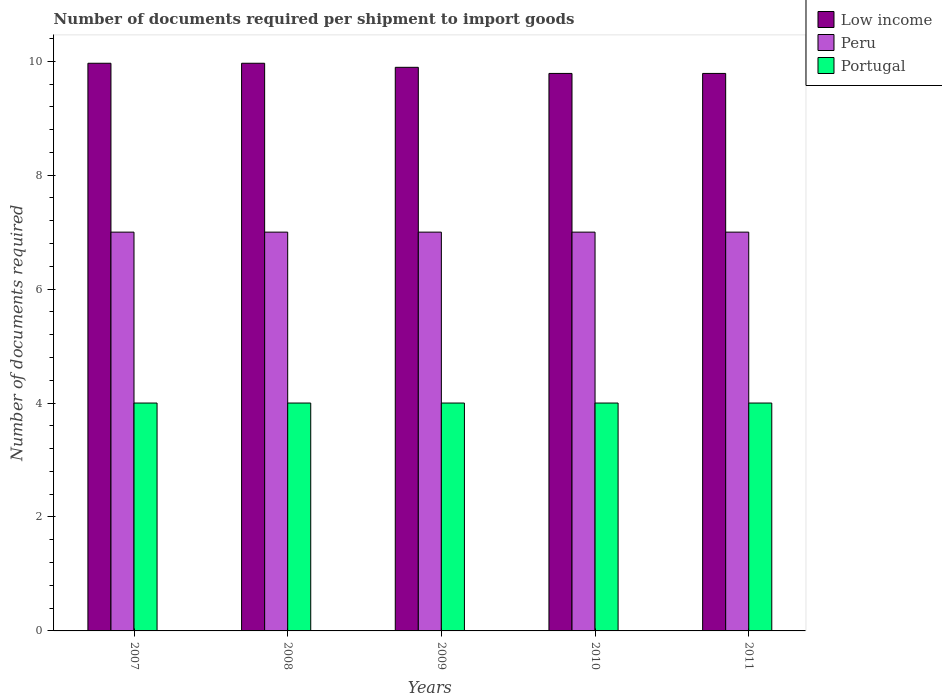Are the number of bars on each tick of the X-axis equal?
Your response must be concise. Yes. How many bars are there on the 5th tick from the left?
Keep it short and to the point. 3. How many bars are there on the 5th tick from the right?
Provide a succinct answer. 3. What is the label of the 1st group of bars from the left?
Provide a succinct answer. 2007. In how many cases, is the number of bars for a given year not equal to the number of legend labels?
Provide a succinct answer. 0. What is the number of documents required per shipment to import goods in Low income in 2007?
Keep it short and to the point. 9.96. Across all years, what is the maximum number of documents required per shipment to import goods in Peru?
Ensure brevity in your answer.  7. Across all years, what is the minimum number of documents required per shipment to import goods in Peru?
Provide a succinct answer. 7. In which year was the number of documents required per shipment to import goods in Peru minimum?
Your answer should be very brief. 2007. What is the total number of documents required per shipment to import goods in Portugal in the graph?
Ensure brevity in your answer.  20. What is the difference between the number of documents required per shipment to import goods in Peru in 2007 and that in 2010?
Give a very brief answer. 0. What is the difference between the number of documents required per shipment to import goods in Portugal in 2011 and the number of documents required per shipment to import goods in Low income in 2009?
Provide a succinct answer. -5.89. What is the average number of documents required per shipment to import goods in Low income per year?
Ensure brevity in your answer.  9.88. In the year 2009, what is the difference between the number of documents required per shipment to import goods in Portugal and number of documents required per shipment to import goods in Peru?
Give a very brief answer. -3. In how many years, is the number of documents required per shipment to import goods in Low income greater than 4?
Your response must be concise. 5. What is the ratio of the number of documents required per shipment to import goods in Portugal in 2007 to that in 2010?
Give a very brief answer. 1. Is the number of documents required per shipment to import goods in Low income in 2010 less than that in 2011?
Your response must be concise. No. What is the difference between the highest and the second highest number of documents required per shipment to import goods in Low income?
Keep it short and to the point. 0. Is the sum of the number of documents required per shipment to import goods in Portugal in 2009 and 2010 greater than the maximum number of documents required per shipment to import goods in Peru across all years?
Your response must be concise. Yes. How many years are there in the graph?
Your answer should be compact. 5. What is the difference between two consecutive major ticks on the Y-axis?
Your response must be concise. 2. Are the values on the major ticks of Y-axis written in scientific E-notation?
Provide a short and direct response. No. How many legend labels are there?
Make the answer very short. 3. How are the legend labels stacked?
Your answer should be very brief. Vertical. What is the title of the graph?
Offer a very short reply. Number of documents required per shipment to import goods. What is the label or title of the X-axis?
Offer a terse response. Years. What is the label or title of the Y-axis?
Keep it short and to the point. Number of documents required. What is the Number of documents required of Low income in 2007?
Give a very brief answer. 9.96. What is the Number of documents required of Portugal in 2007?
Give a very brief answer. 4. What is the Number of documents required of Low income in 2008?
Provide a succinct answer. 9.96. What is the Number of documents required of Low income in 2009?
Offer a terse response. 9.89. What is the Number of documents required of Peru in 2009?
Keep it short and to the point. 7. What is the Number of documents required of Low income in 2010?
Ensure brevity in your answer.  9.79. What is the Number of documents required in Portugal in 2010?
Offer a very short reply. 4. What is the Number of documents required of Low income in 2011?
Offer a very short reply. 9.79. What is the Number of documents required of Peru in 2011?
Provide a succinct answer. 7. Across all years, what is the maximum Number of documents required in Low income?
Offer a terse response. 9.96. Across all years, what is the maximum Number of documents required of Peru?
Give a very brief answer. 7. Across all years, what is the minimum Number of documents required in Low income?
Your answer should be very brief. 9.79. Across all years, what is the minimum Number of documents required of Peru?
Provide a short and direct response. 7. What is the total Number of documents required in Low income in the graph?
Give a very brief answer. 49.39. What is the total Number of documents required of Portugal in the graph?
Ensure brevity in your answer.  20. What is the difference between the Number of documents required in Low income in 2007 and that in 2008?
Make the answer very short. 0. What is the difference between the Number of documents required of Peru in 2007 and that in 2008?
Provide a succinct answer. 0. What is the difference between the Number of documents required of Portugal in 2007 and that in 2008?
Ensure brevity in your answer.  0. What is the difference between the Number of documents required of Low income in 2007 and that in 2009?
Make the answer very short. 0.07. What is the difference between the Number of documents required in Peru in 2007 and that in 2009?
Provide a short and direct response. 0. What is the difference between the Number of documents required of Low income in 2007 and that in 2010?
Offer a terse response. 0.18. What is the difference between the Number of documents required of Low income in 2007 and that in 2011?
Provide a short and direct response. 0.18. What is the difference between the Number of documents required of Peru in 2007 and that in 2011?
Offer a terse response. 0. What is the difference between the Number of documents required of Portugal in 2007 and that in 2011?
Your response must be concise. 0. What is the difference between the Number of documents required of Low income in 2008 and that in 2009?
Provide a short and direct response. 0.07. What is the difference between the Number of documents required in Peru in 2008 and that in 2009?
Ensure brevity in your answer.  0. What is the difference between the Number of documents required in Portugal in 2008 and that in 2009?
Give a very brief answer. 0. What is the difference between the Number of documents required of Low income in 2008 and that in 2010?
Give a very brief answer. 0.18. What is the difference between the Number of documents required of Peru in 2008 and that in 2010?
Your answer should be compact. 0. What is the difference between the Number of documents required of Low income in 2008 and that in 2011?
Provide a succinct answer. 0.18. What is the difference between the Number of documents required of Peru in 2008 and that in 2011?
Give a very brief answer. 0. What is the difference between the Number of documents required of Portugal in 2008 and that in 2011?
Give a very brief answer. 0. What is the difference between the Number of documents required in Low income in 2009 and that in 2010?
Keep it short and to the point. 0.11. What is the difference between the Number of documents required of Peru in 2009 and that in 2010?
Your answer should be very brief. 0. What is the difference between the Number of documents required in Low income in 2009 and that in 2011?
Give a very brief answer. 0.11. What is the difference between the Number of documents required of Low income in 2010 and that in 2011?
Provide a succinct answer. 0. What is the difference between the Number of documents required in Peru in 2010 and that in 2011?
Make the answer very short. 0. What is the difference between the Number of documents required of Portugal in 2010 and that in 2011?
Keep it short and to the point. 0. What is the difference between the Number of documents required in Low income in 2007 and the Number of documents required in Peru in 2008?
Your answer should be very brief. 2.96. What is the difference between the Number of documents required in Low income in 2007 and the Number of documents required in Portugal in 2008?
Keep it short and to the point. 5.96. What is the difference between the Number of documents required in Peru in 2007 and the Number of documents required in Portugal in 2008?
Ensure brevity in your answer.  3. What is the difference between the Number of documents required in Low income in 2007 and the Number of documents required in Peru in 2009?
Keep it short and to the point. 2.96. What is the difference between the Number of documents required in Low income in 2007 and the Number of documents required in Portugal in 2009?
Give a very brief answer. 5.96. What is the difference between the Number of documents required of Low income in 2007 and the Number of documents required of Peru in 2010?
Ensure brevity in your answer.  2.96. What is the difference between the Number of documents required of Low income in 2007 and the Number of documents required of Portugal in 2010?
Give a very brief answer. 5.96. What is the difference between the Number of documents required of Peru in 2007 and the Number of documents required of Portugal in 2010?
Your answer should be very brief. 3. What is the difference between the Number of documents required in Low income in 2007 and the Number of documents required in Peru in 2011?
Keep it short and to the point. 2.96. What is the difference between the Number of documents required in Low income in 2007 and the Number of documents required in Portugal in 2011?
Ensure brevity in your answer.  5.96. What is the difference between the Number of documents required of Peru in 2007 and the Number of documents required of Portugal in 2011?
Provide a succinct answer. 3. What is the difference between the Number of documents required of Low income in 2008 and the Number of documents required of Peru in 2009?
Provide a succinct answer. 2.96. What is the difference between the Number of documents required in Low income in 2008 and the Number of documents required in Portugal in 2009?
Offer a terse response. 5.96. What is the difference between the Number of documents required in Low income in 2008 and the Number of documents required in Peru in 2010?
Offer a very short reply. 2.96. What is the difference between the Number of documents required of Low income in 2008 and the Number of documents required of Portugal in 2010?
Keep it short and to the point. 5.96. What is the difference between the Number of documents required of Peru in 2008 and the Number of documents required of Portugal in 2010?
Your response must be concise. 3. What is the difference between the Number of documents required of Low income in 2008 and the Number of documents required of Peru in 2011?
Offer a terse response. 2.96. What is the difference between the Number of documents required in Low income in 2008 and the Number of documents required in Portugal in 2011?
Provide a succinct answer. 5.96. What is the difference between the Number of documents required of Peru in 2008 and the Number of documents required of Portugal in 2011?
Keep it short and to the point. 3. What is the difference between the Number of documents required in Low income in 2009 and the Number of documents required in Peru in 2010?
Your response must be concise. 2.89. What is the difference between the Number of documents required of Low income in 2009 and the Number of documents required of Portugal in 2010?
Keep it short and to the point. 5.89. What is the difference between the Number of documents required in Peru in 2009 and the Number of documents required in Portugal in 2010?
Provide a succinct answer. 3. What is the difference between the Number of documents required of Low income in 2009 and the Number of documents required of Peru in 2011?
Make the answer very short. 2.89. What is the difference between the Number of documents required of Low income in 2009 and the Number of documents required of Portugal in 2011?
Your answer should be compact. 5.89. What is the difference between the Number of documents required in Peru in 2009 and the Number of documents required in Portugal in 2011?
Ensure brevity in your answer.  3. What is the difference between the Number of documents required of Low income in 2010 and the Number of documents required of Peru in 2011?
Offer a terse response. 2.79. What is the difference between the Number of documents required in Low income in 2010 and the Number of documents required in Portugal in 2011?
Make the answer very short. 5.79. What is the average Number of documents required in Low income per year?
Ensure brevity in your answer.  9.88. What is the average Number of documents required in Portugal per year?
Your answer should be very brief. 4. In the year 2007, what is the difference between the Number of documents required in Low income and Number of documents required in Peru?
Provide a short and direct response. 2.96. In the year 2007, what is the difference between the Number of documents required of Low income and Number of documents required of Portugal?
Provide a succinct answer. 5.96. In the year 2007, what is the difference between the Number of documents required of Peru and Number of documents required of Portugal?
Keep it short and to the point. 3. In the year 2008, what is the difference between the Number of documents required in Low income and Number of documents required in Peru?
Keep it short and to the point. 2.96. In the year 2008, what is the difference between the Number of documents required of Low income and Number of documents required of Portugal?
Keep it short and to the point. 5.96. In the year 2008, what is the difference between the Number of documents required in Peru and Number of documents required in Portugal?
Your answer should be very brief. 3. In the year 2009, what is the difference between the Number of documents required in Low income and Number of documents required in Peru?
Your response must be concise. 2.89. In the year 2009, what is the difference between the Number of documents required of Low income and Number of documents required of Portugal?
Your answer should be compact. 5.89. In the year 2009, what is the difference between the Number of documents required in Peru and Number of documents required in Portugal?
Make the answer very short. 3. In the year 2010, what is the difference between the Number of documents required of Low income and Number of documents required of Peru?
Make the answer very short. 2.79. In the year 2010, what is the difference between the Number of documents required of Low income and Number of documents required of Portugal?
Your answer should be compact. 5.79. In the year 2011, what is the difference between the Number of documents required of Low income and Number of documents required of Peru?
Provide a succinct answer. 2.79. In the year 2011, what is the difference between the Number of documents required of Low income and Number of documents required of Portugal?
Offer a terse response. 5.79. What is the ratio of the Number of documents required in Low income in 2007 to that in 2008?
Your answer should be very brief. 1. What is the ratio of the Number of documents required of Portugal in 2007 to that in 2008?
Offer a very short reply. 1. What is the ratio of the Number of documents required of Low income in 2007 to that in 2009?
Offer a terse response. 1.01. What is the ratio of the Number of documents required of Peru in 2007 to that in 2009?
Make the answer very short. 1. What is the ratio of the Number of documents required of Portugal in 2007 to that in 2009?
Your answer should be compact. 1. What is the ratio of the Number of documents required in Low income in 2007 to that in 2010?
Your answer should be very brief. 1.02. What is the ratio of the Number of documents required in Peru in 2007 to that in 2010?
Your answer should be compact. 1. What is the ratio of the Number of documents required in Portugal in 2007 to that in 2010?
Provide a succinct answer. 1. What is the ratio of the Number of documents required of Low income in 2007 to that in 2011?
Offer a terse response. 1.02. What is the ratio of the Number of documents required of Peru in 2008 to that in 2009?
Your response must be concise. 1. What is the ratio of the Number of documents required of Portugal in 2008 to that in 2009?
Provide a succinct answer. 1. What is the ratio of the Number of documents required in Low income in 2008 to that in 2010?
Keep it short and to the point. 1.02. What is the ratio of the Number of documents required of Low income in 2008 to that in 2011?
Give a very brief answer. 1.02. What is the ratio of the Number of documents required of Peru in 2008 to that in 2011?
Give a very brief answer. 1. What is the ratio of the Number of documents required of Portugal in 2008 to that in 2011?
Provide a short and direct response. 1. What is the ratio of the Number of documents required of Low income in 2009 to that in 2010?
Offer a very short reply. 1.01. What is the ratio of the Number of documents required of Portugal in 2009 to that in 2010?
Offer a terse response. 1. What is the ratio of the Number of documents required in Low income in 2009 to that in 2011?
Offer a terse response. 1.01. What is the ratio of the Number of documents required in Low income in 2010 to that in 2011?
Keep it short and to the point. 1. What is the ratio of the Number of documents required in Peru in 2010 to that in 2011?
Provide a short and direct response. 1. What is the ratio of the Number of documents required of Portugal in 2010 to that in 2011?
Ensure brevity in your answer.  1. What is the difference between the highest and the second highest Number of documents required of Low income?
Your answer should be compact. 0. What is the difference between the highest and the lowest Number of documents required in Low income?
Provide a short and direct response. 0.18. What is the difference between the highest and the lowest Number of documents required of Peru?
Your answer should be very brief. 0. What is the difference between the highest and the lowest Number of documents required of Portugal?
Offer a very short reply. 0. 